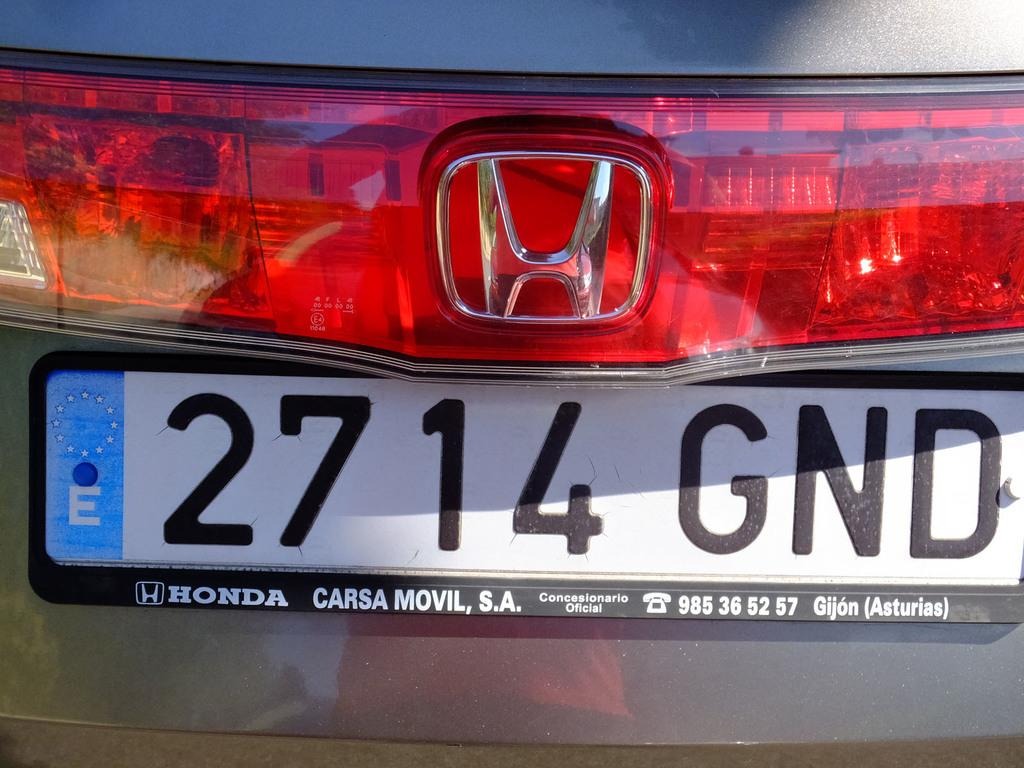<image>
Create a compact narrative representing the image presented. The license plate of a silver honda reads 27 14 GND. 